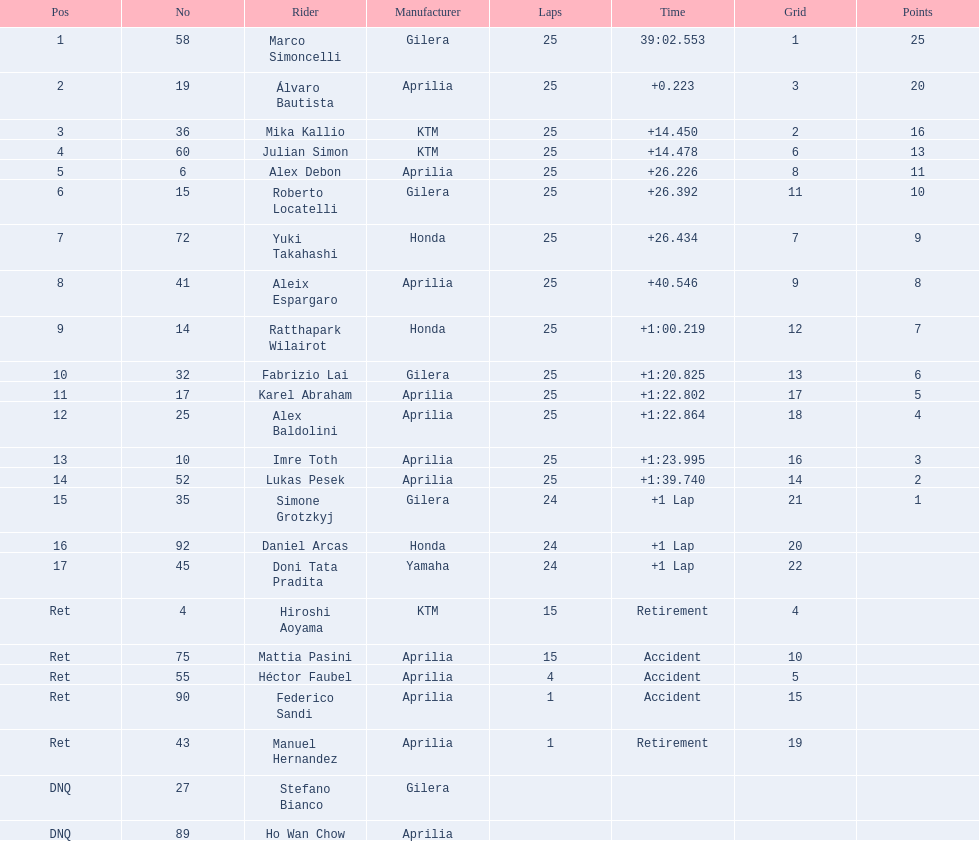Can you provide the names of all riders? Marco Simoncelli, Álvaro Bautista, Mika Kallio, Julian Simon, Alex Debon, Roberto Locatelli, Yuki Takahashi, Aleix Espargaro, Ratthapark Wilairot, Fabrizio Lai, Karel Abraham, Alex Baldolini, Imre Toth, Lukas Pesek, Simone Grotzkyj, Daniel Arcas, Doni Tata Pradita, Hiroshi Aoyama, Mattia Pasini, Héctor Faubel, Federico Sandi, Manuel Hernandez, Stefano Bianco, Ho Wan Chow. How many laps did each finish? 25, 25, 25, 25, 25, 25, 25, 25, 25, 25, 25, 25, 25, 25, 24, 24, 24, 15, 15, 4, 1, 1, , . Did marco simoncelli or hiroshi aoyama have a higher number of laps? Marco Simoncelli. 